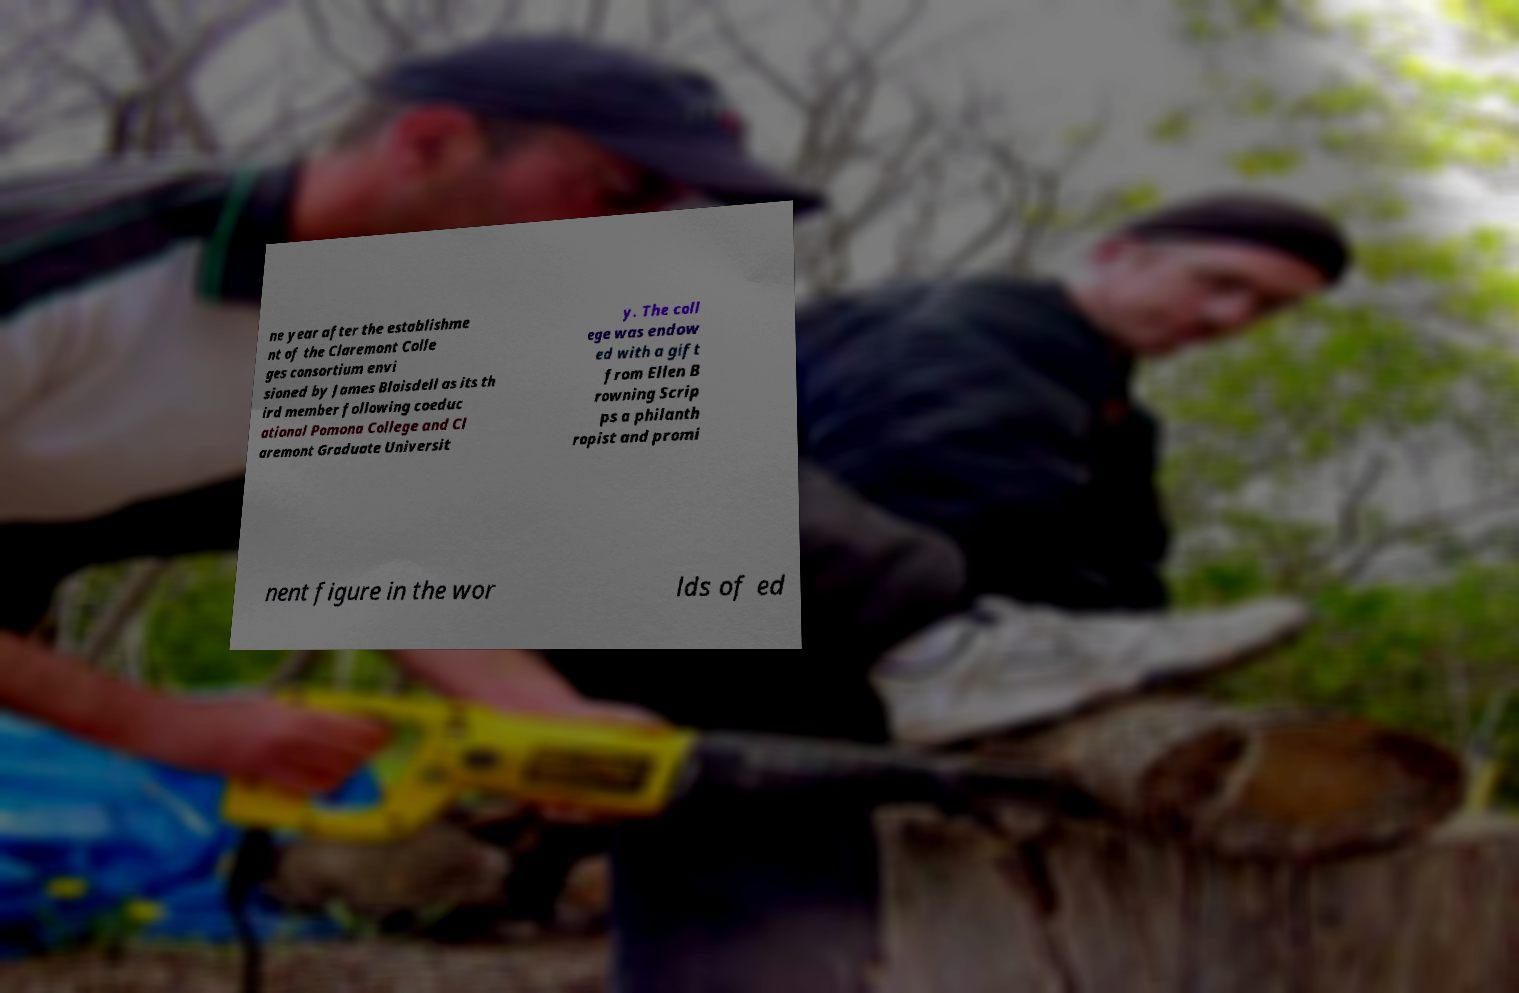What messages or text are displayed in this image? I need them in a readable, typed format. ne year after the establishme nt of the Claremont Colle ges consortium envi sioned by James Blaisdell as its th ird member following coeduc ational Pomona College and Cl aremont Graduate Universit y. The coll ege was endow ed with a gift from Ellen B rowning Scrip ps a philanth ropist and promi nent figure in the wor lds of ed 